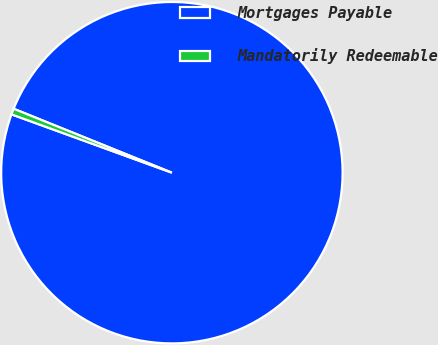Convert chart to OTSL. <chart><loc_0><loc_0><loc_500><loc_500><pie_chart><fcel>Mortgages Payable<fcel>Mandatorily Redeemable<nl><fcel>99.44%<fcel>0.56%<nl></chart> 